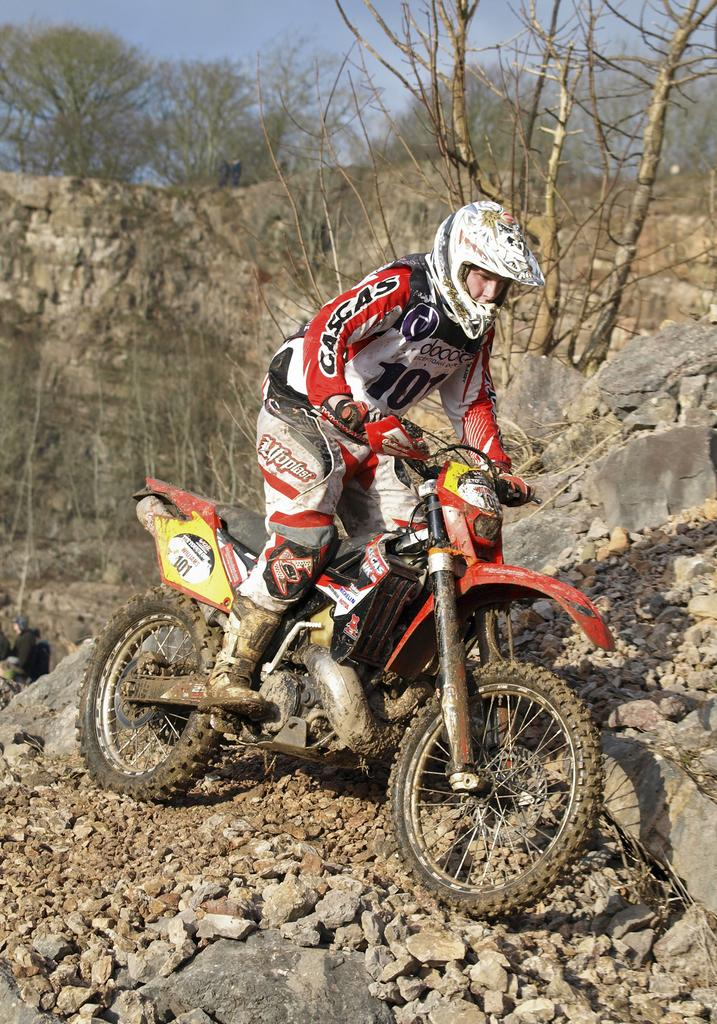Where was the picture taken? The picture was clicked outside. Can you describe the person in the image? There is a person in the image, and they are wearing a white color helmet. What activity is the person engaged in? The person appears to be riding a bike. What type of terrain can be seen in the image? There are rocks visible in the image. What other natural elements are present in the image? There are trees and the sky visible in the image. What type of advertisement can be seen on the person's finger in the image? There is no advertisement visible on the person's finger in the image, as they are wearing a helmet and riding a bike. 